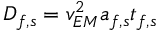<formula> <loc_0><loc_0><loc_500><loc_500>D _ { f , s } = v _ { E M } ^ { 2 } a _ { f , s } t _ { f , s }</formula> 